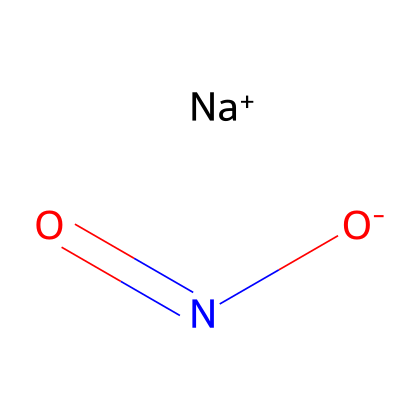What is the total number of atoms in sodium nitrite? The SMILES representation breaks down into sodium (Na), nitrogen (N), and oxygen (O). Counting these gives us 1 sodium, 1 nitrogen, and 2 oxygen atoms, totaling three atoms.
Answer: 3 How many oxygen atoms are present in sodium nitrite? From the SMILES, we can see there are two oxygen (O) atoms indicated in the structure of sodium nitrite.
Answer: 2 Does sodium nitrite contain a double bond? The SMILES notation reveals a double bond between the nitrogen (N) and one of the oxygen (O) atoms, indicating that yes, there is a double bond present.
Answer: yes What is the formal charge on sodium (Na) in sodium nitrite? In the SMILES representation, sodium is shown as [Na+], which indicates a formal charge of +1, indicating it has lost one electron.
Answer: +1 Is sodium nitrite classified as an ionic or covalent compound? The presence of a charged sodium ion (Na+) and a nitrite ion (NO2-) signifies the ionic nature of sodium nitrite, as it contains a metal and a non-metal combination.
Answer: ionic What is the potential role of sodium nitrite in food preservation? Sodium nitrite is commonly used to inhibit microbial growth, particularly Clostridium botulinum, which is responsible for botulism, ensuring food safety and extending shelf life.
Answer: preservation 